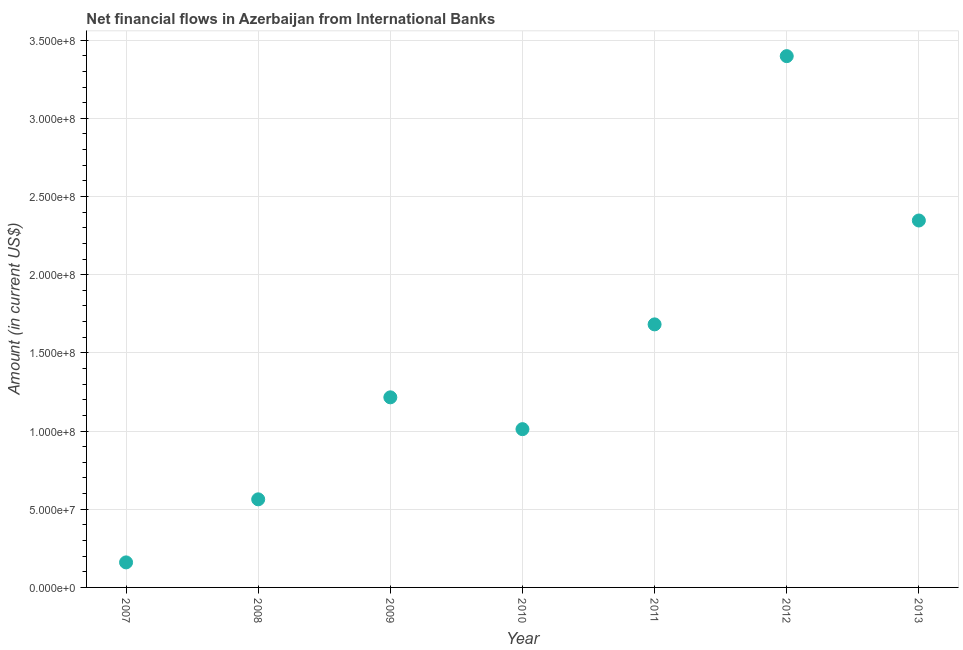What is the net financial flows from ibrd in 2010?
Offer a very short reply. 1.01e+08. Across all years, what is the maximum net financial flows from ibrd?
Ensure brevity in your answer.  3.40e+08. Across all years, what is the minimum net financial flows from ibrd?
Keep it short and to the point. 1.60e+07. In which year was the net financial flows from ibrd maximum?
Ensure brevity in your answer.  2012. What is the sum of the net financial flows from ibrd?
Your answer should be compact. 1.04e+09. What is the difference between the net financial flows from ibrd in 2009 and 2013?
Make the answer very short. -1.13e+08. What is the average net financial flows from ibrd per year?
Make the answer very short. 1.48e+08. What is the median net financial flows from ibrd?
Offer a very short reply. 1.22e+08. In how many years, is the net financial flows from ibrd greater than 210000000 US$?
Your response must be concise. 2. Do a majority of the years between 2012 and 2008 (inclusive) have net financial flows from ibrd greater than 110000000 US$?
Make the answer very short. Yes. What is the ratio of the net financial flows from ibrd in 2008 to that in 2013?
Ensure brevity in your answer.  0.24. Is the net financial flows from ibrd in 2007 less than that in 2013?
Offer a very short reply. Yes. Is the difference between the net financial flows from ibrd in 2008 and 2011 greater than the difference between any two years?
Provide a short and direct response. No. What is the difference between the highest and the second highest net financial flows from ibrd?
Your answer should be very brief. 1.05e+08. What is the difference between the highest and the lowest net financial flows from ibrd?
Give a very brief answer. 3.24e+08. Does the net financial flows from ibrd monotonically increase over the years?
Provide a short and direct response. No. How many dotlines are there?
Provide a succinct answer. 1. How many years are there in the graph?
Ensure brevity in your answer.  7. What is the difference between two consecutive major ticks on the Y-axis?
Your response must be concise. 5.00e+07. Are the values on the major ticks of Y-axis written in scientific E-notation?
Keep it short and to the point. Yes. Does the graph contain grids?
Your answer should be very brief. Yes. What is the title of the graph?
Make the answer very short. Net financial flows in Azerbaijan from International Banks. What is the label or title of the X-axis?
Keep it short and to the point. Year. What is the Amount (in current US$) in 2007?
Keep it short and to the point. 1.60e+07. What is the Amount (in current US$) in 2008?
Your answer should be very brief. 5.63e+07. What is the Amount (in current US$) in 2009?
Your answer should be very brief. 1.22e+08. What is the Amount (in current US$) in 2010?
Your response must be concise. 1.01e+08. What is the Amount (in current US$) in 2011?
Give a very brief answer. 1.68e+08. What is the Amount (in current US$) in 2012?
Provide a succinct answer. 3.40e+08. What is the Amount (in current US$) in 2013?
Provide a short and direct response. 2.35e+08. What is the difference between the Amount (in current US$) in 2007 and 2008?
Offer a very short reply. -4.03e+07. What is the difference between the Amount (in current US$) in 2007 and 2009?
Provide a short and direct response. -1.06e+08. What is the difference between the Amount (in current US$) in 2007 and 2010?
Offer a very short reply. -8.52e+07. What is the difference between the Amount (in current US$) in 2007 and 2011?
Your response must be concise. -1.52e+08. What is the difference between the Amount (in current US$) in 2007 and 2012?
Make the answer very short. -3.24e+08. What is the difference between the Amount (in current US$) in 2007 and 2013?
Provide a short and direct response. -2.19e+08. What is the difference between the Amount (in current US$) in 2008 and 2009?
Your answer should be very brief. -6.52e+07. What is the difference between the Amount (in current US$) in 2008 and 2010?
Keep it short and to the point. -4.49e+07. What is the difference between the Amount (in current US$) in 2008 and 2011?
Your response must be concise. -1.12e+08. What is the difference between the Amount (in current US$) in 2008 and 2012?
Provide a short and direct response. -2.83e+08. What is the difference between the Amount (in current US$) in 2008 and 2013?
Give a very brief answer. -1.78e+08. What is the difference between the Amount (in current US$) in 2009 and 2010?
Keep it short and to the point. 2.04e+07. What is the difference between the Amount (in current US$) in 2009 and 2011?
Offer a very short reply. -4.66e+07. What is the difference between the Amount (in current US$) in 2009 and 2012?
Make the answer very short. -2.18e+08. What is the difference between the Amount (in current US$) in 2009 and 2013?
Ensure brevity in your answer.  -1.13e+08. What is the difference between the Amount (in current US$) in 2010 and 2011?
Your response must be concise. -6.70e+07. What is the difference between the Amount (in current US$) in 2010 and 2012?
Keep it short and to the point. -2.39e+08. What is the difference between the Amount (in current US$) in 2010 and 2013?
Give a very brief answer. -1.33e+08. What is the difference between the Amount (in current US$) in 2011 and 2012?
Your answer should be compact. -1.72e+08. What is the difference between the Amount (in current US$) in 2011 and 2013?
Offer a terse response. -6.64e+07. What is the difference between the Amount (in current US$) in 2012 and 2013?
Offer a very short reply. 1.05e+08. What is the ratio of the Amount (in current US$) in 2007 to that in 2008?
Offer a terse response. 0.28. What is the ratio of the Amount (in current US$) in 2007 to that in 2009?
Keep it short and to the point. 0.13. What is the ratio of the Amount (in current US$) in 2007 to that in 2010?
Provide a succinct answer. 0.16. What is the ratio of the Amount (in current US$) in 2007 to that in 2011?
Provide a short and direct response. 0.1. What is the ratio of the Amount (in current US$) in 2007 to that in 2012?
Give a very brief answer. 0.05. What is the ratio of the Amount (in current US$) in 2007 to that in 2013?
Give a very brief answer. 0.07. What is the ratio of the Amount (in current US$) in 2008 to that in 2009?
Keep it short and to the point. 0.46. What is the ratio of the Amount (in current US$) in 2008 to that in 2010?
Your response must be concise. 0.56. What is the ratio of the Amount (in current US$) in 2008 to that in 2011?
Offer a terse response. 0.34. What is the ratio of the Amount (in current US$) in 2008 to that in 2012?
Provide a short and direct response. 0.17. What is the ratio of the Amount (in current US$) in 2008 to that in 2013?
Offer a terse response. 0.24. What is the ratio of the Amount (in current US$) in 2009 to that in 2010?
Offer a very short reply. 1.2. What is the ratio of the Amount (in current US$) in 2009 to that in 2011?
Offer a very short reply. 0.72. What is the ratio of the Amount (in current US$) in 2009 to that in 2012?
Provide a succinct answer. 0.36. What is the ratio of the Amount (in current US$) in 2009 to that in 2013?
Ensure brevity in your answer.  0.52. What is the ratio of the Amount (in current US$) in 2010 to that in 2011?
Give a very brief answer. 0.6. What is the ratio of the Amount (in current US$) in 2010 to that in 2012?
Keep it short and to the point. 0.3. What is the ratio of the Amount (in current US$) in 2010 to that in 2013?
Give a very brief answer. 0.43. What is the ratio of the Amount (in current US$) in 2011 to that in 2012?
Your answer should be compact. 0.49. What is the ratio of the Amount (in current US$) in 2011 to that in 2013?
Ensure brevity in your answer.  0.72. What is the ratio of the Amount (in current US$) in 2012 to that in 2013?
Provide a succinct answer. 1.45. 